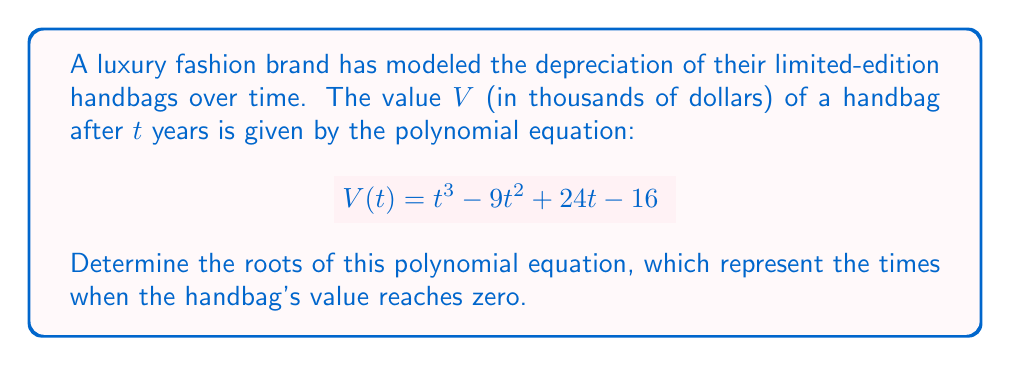Give your solution to this math problem. To find the roots of this polynomial equation, we need to factor the polynomial and solve for $t$ when $V(t) = 0$.

1) First, let's set the equation equal to zero:
   $$t^3 - 9t^2 + 24t - 16 = 0$$

2) This is a cubic equation. Let's try to guess one root. Given the constant term is 16, possible factors could be ±1, ±2, ±4, ±8, ±16. After trying these, we find that $t = 1$ is a root.

3) Using polynomial long division or the factor theorem, we can divide the original polynomial by $(t - 1)$:

   $$(t^3 - 9t^2 + 24t - 16) \div (t - 1) = t^2 - 8t + 16$$

4) So our polynomial can be factored as:
   $$t^3 - 9t^2 + 24t - 16 = (t - 1)(t^2 - 8t + 16)$$

5) Now we need to solve $t^2 - 8t + 16 = 0$

6) This is a quadratic equation. We can solve it using the quadratic formula:
   $$t = \frac{-b \pm \sqrt{b^2 - 4ac}}{2a}$$
   where $a = 1$, $b = -8$, and $c = 16$

7) Substituting these values:
   $$t = \frac{8 \pm \sqrt{64 - 64}}{2} = \frac{8 \pm 0}{2} = 4$$

8) Therefore, the quadratic factor $(t^2 - 8t + 16)$ can be written as $(t - 4)(t - 4)$ or $(t - 4)^2$

Thus, the fully factored polynomial is:
$$(t - 1)(t - 4)^2 = 0$$
Answer: The roots of the polynomial equation are $t = 1$ and $t = 4$ (double root). These represent the times (in years) when the handbag's value reaches zero. 